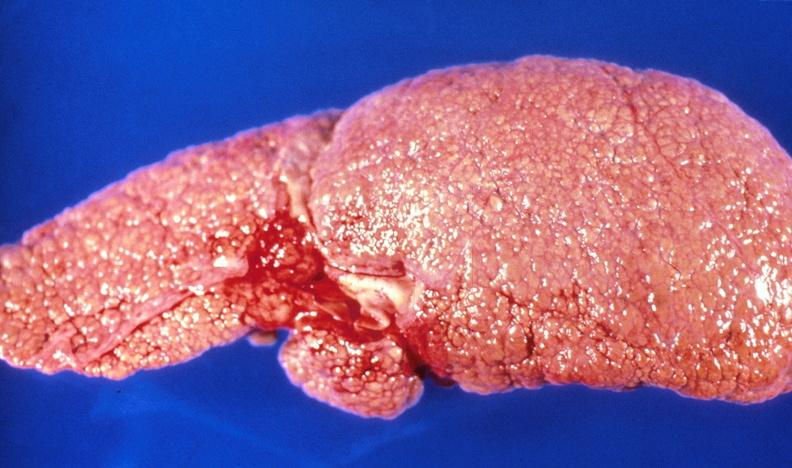does sugar coated show alcoholic cirrhosis?
Answer the question using a single word or phrase. No 